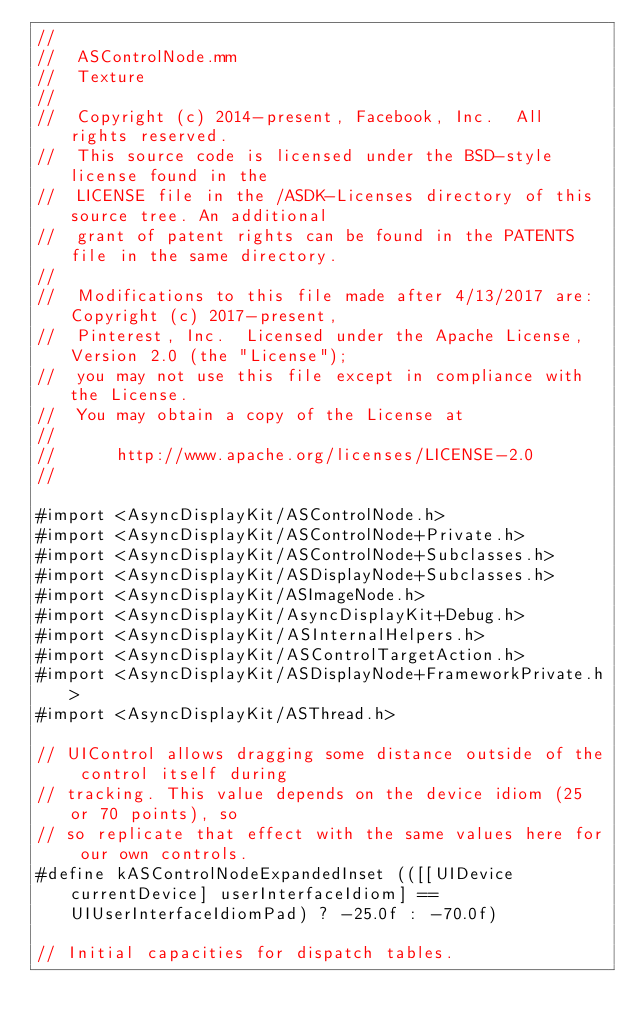<code> <loc_0><loc_0><loc_500><loc_500><_ObjectiveC_>//
//  ASControlNode.mm
//  Texture
//
//  Copyright (c) 2014-present, Facebook, Inc.  All rights reserved.
//  This source code is licensed under the BSD-style license found in the
//  LICENSE file in the /ASDK-Licenses directory of this source tree. An additional
//  grant of patent rights can be found in the PATENTS file in the same directory.
//
//  Modifications to this file made after 4/13/2017 are: Copyright (c) 2017-present,
//  Pinterest, Inc.  Licensed under the Apache License, Version 2.0 (the "License");
//  you may not use this file except in compliance with the License.
//  You may obtain a copy of the License at
//
//      http://www.apache.org/licenses/LICENSE-2.0
//

#import <AsyncDisplayKit/ASControlNode.h>
#import <AsyncDisplayKit/ASControlNode+Private.h>
#import <AsyncDisplayKit/ASControlNode+Subclasses.h>
#import <AsyncDisplayKit/ASDisplayNode+Subclasses.h>
#import <AsyncDisplayKit/ASImageNode.h>
#import <AsyncDisplayKit/AsyncDisplayKit+Debug.h>
#import <AsyncDisplayKit/ASInternalHelpers.h>
#import <AsyncDisplayKit/ASControlTargetAction.h>
#import <AsyncDisplayKit/ASDisplayNode+FrameworkPrivate.h>
#import <AsyncDisplayKit/ASThread.h>

// UIControl allows dragging some distance outside of the control itself during
// tracking. This value depends on the device idiom (25 or 70 points), so
// so replicate that effect with the same values here for our own controls.
#define kASControlNodeExpandedInset (([[UIDevice currentDevice] userInterfaceIdiom] == UIUserInterfaceIdiomPad) ? -25.0f : -70.0f)

// Initial capacities for dispatch tables.</code> 